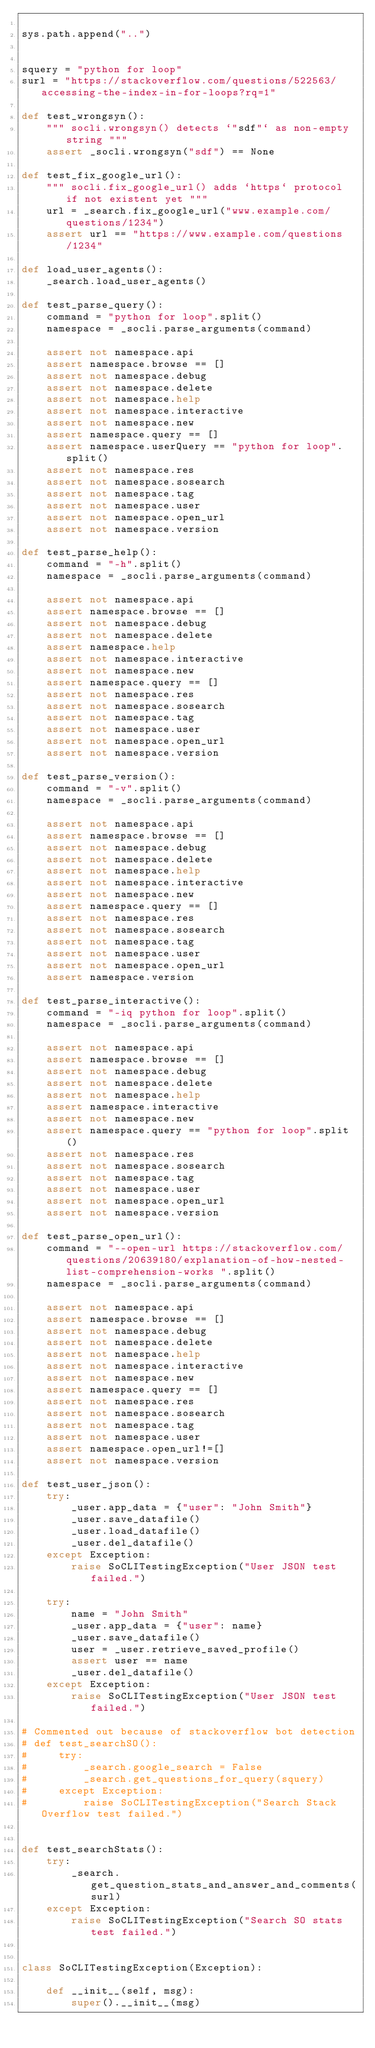<code> <loc_0><loc_0><loc_500><loc_500><_Python_>
sys.path.append("..")


squery = "python for loop"
surl = "https://stackoverflow.com/questions/522563/accessing-the-index-in-for-loops?rq=1"

def test_wrongsyn():
    """ socli.wrongsyn() detects `"sdf"` as non-empty string """
    assert _socli.wrongsyn("sdf") == None

def test_fix_google_url():
    """ socli.fix_google_url() adds `https` protocol if not existent yet """
    url = _search.fix_google_url("www.example.com/questions/1234")
    assert url == "https://www.example.com/questions/1234"

def load_user_agents():
    _search.load_user_agents()

def test_parse_query():
    command = "python for loop".split()
    namespace = _socli.parse_arguments(command)

    assert not namespace.api
    assert namespace.browse == []
    assert not namespace.debug
    assert not namespace.delete
    assert not namespace.help
    assert not namespace.interactive
    assert not namespace.new
    assert namespace.query == []
    assert namespace.userQuery == "python for loop".split()
    assert not namespace.res
    assert not namespace.sosearch
    assert not namespace.tag
    assert not namespace.user
    assert not namespace.open_url
    assert not namespace.version

def test_parse_help():
    command = "-h".split()
    namespace = _socli.parse_arguments(command)

    assert not namespace.api
    assert namespace.browse == []
    assert not namespace.debug
    assert not namespace.delete
    assert namespace.help
    assert not namespace.interactive
    assert not namespace.new
    assert namespace.query == []
    assert not namespace.res
    assert not namespace.sosearch
    assert not namespace.tag
    assert not namespace.user
    assert not namespace.open_url
    assert not namespace.version

def test_parse_version():
    command = "-v".split()
    namespace = _socli.parse_arguments(command)

    assert not namespace.api
    assert namespace.browse == []
    assert not namespace.debug
    assert not namespace.delete
    assert not namespace.help
    assert not namespace.interactive
    assert not namespace.new
    assert namespace.query == []
    assert not namespace.res
    assert not namespace.sosearch
    assert not namespace.tag
    assert not namespace.user
    assert not namespace.open_url
    assert namespace.version

def test_parse_interactive():
    command = "-iq python for loop".split()
    namespace = _socli.parse_arguments(command)

    assert not namespace.api
    assert namespace.browse == []
    assert not namespace.debug
    assert not namespace.delete
    assert not namespace.help
    assert namespace.interactive
    assert not namespace.new
    assert namespace.query == "python for loop".split()
    assert not namespace.res
    assert not namespace.sosearch
    assert not namespace.tag
    assert not namespace.user
    assert not namespace.open_url
    assert not namespace.version

def test_parse_open_url():
    command = "--open-url https://stackoverflow.com/questions/20639180/explanation-of-how-nested-list-comprehension-works ".split()
    namespace = _socli.parse_arguments(command)

    assert not namespace.api
    assert namespace.browse == []
    assert not namespace.debug
    assert not namespace.delete
    assert not namespace.help
    assert not namespace.interactive
    assert not namespace.new
    assert namespace.query == []
    assert not namespace.res
    assert not namespace.sosearch
    assert not namespace.tag
    assert not namespace.user
    assert namespace.open_url!=[]
    assert not namespace.version

def test_user_json():
    try:
        _user.app_data = {"user": "John Smith"}
        _user.save_datafile()
        _user.load_datafile()
        _user.del_datafile()
    except Exception:
        raise SoCLITestingException("User JSON test failed.")

    try:
        name = "John Smith"
        _user.app_data = {"user": name}
        _user.save_datafile()
        user = _user.retrieve_saved_profile()
        assert user == name
        _user.del_datafile()
    except Exception:
        raise SoCLITestingException("User JSON test failed.")

# Commented out because of stackoverflow bot detection
# def test_searchSO():
#     try:
#         _search.google_search = False
#         _search.get_questions_for_query(squery)
#     except Exception:
#         raise SoCLITestingException("Search Stack Overflow test failed.")


def test_searchStats():
    try:
        _search.get_question_stats_and_answer_and_comments(surl)
    except Exception:
        raise SoCLITestingException("Search SO stats test failed.")


class SoCLITestingException(Exception):

    def __init__(self, msg):
        super().__init__(msg)
</code> 